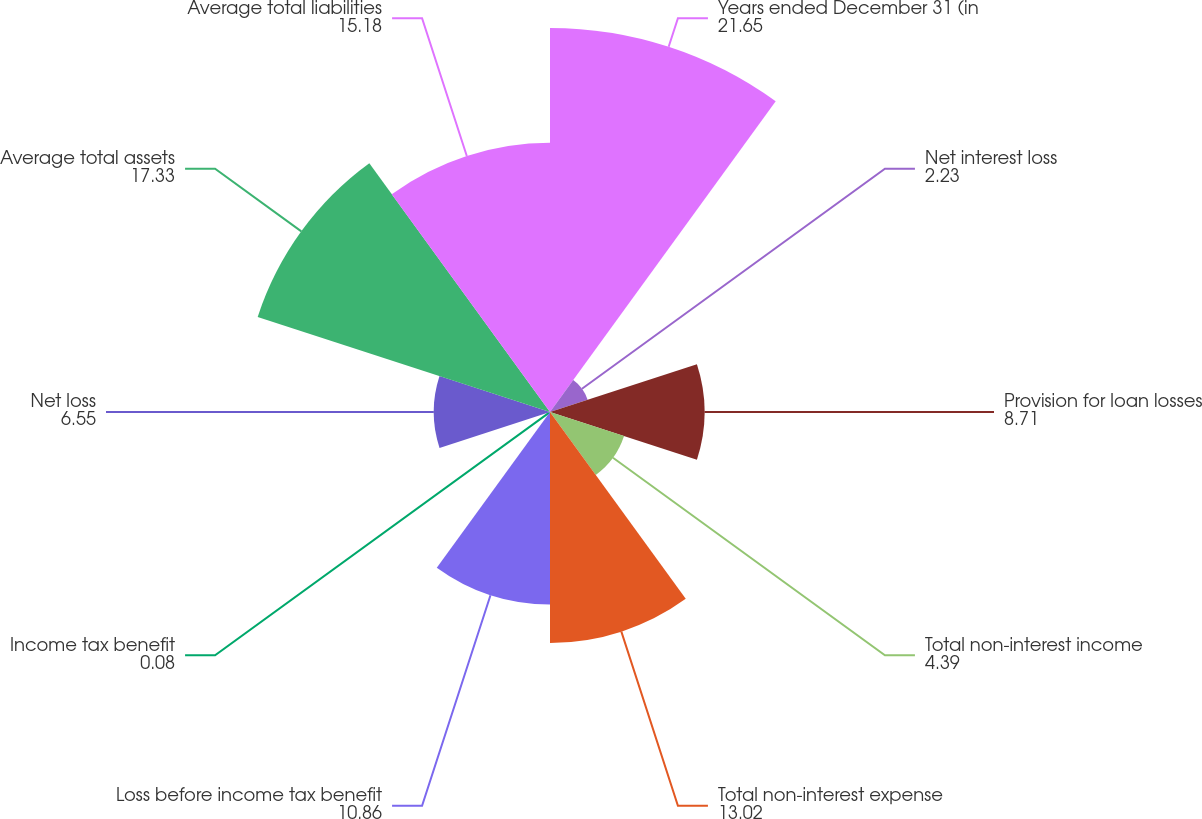Convert chart. <chart><loc_0><loc_0><loc_500><loc_500><pie_chart><fcel>Years ended December 31 (in<fcel>Net interest loss<fcel>Provision for loan losses<fcel>Total non-interest income<fcel>Total non-interest expense<fcel>Loss before income tax benefit<fcel>Income tax benefit<fcel>Net loss<fcel>Average total assets<fcel>Average total liabilities<nl><fcel>21.65%<fcel>2.23%<fcel>8.71%<fcel>4.39%<fcel>13.02%<fcel>10.86%<fcel>0.08%<fcel>6.55%<fcel>17.33%<fcel>15.18%<nl></chart> 